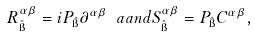Convert formula to latex. <formula><loc_0><loc_0><loc_500><loc_500>R _ { \hat { \i } } ^ { \alpha \beta } = i P _ { \hat { \i } } \partial ^ { \alpha \beta } \ a a n d S _ { \hat { \i } } ^ { \alpha \beta } = P _ { \hat { \i } } C ^ { \alpha \beta } ,</formula> 